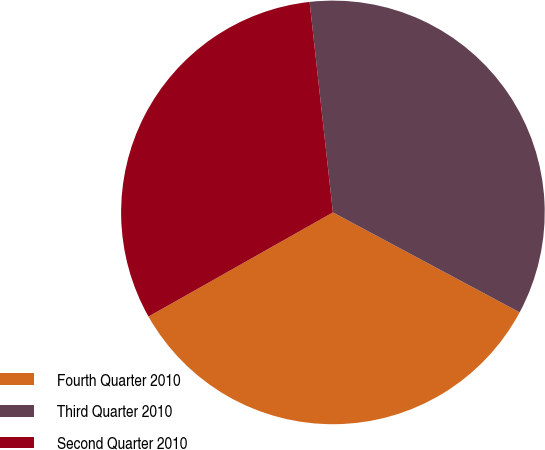Convert chart. <chart><loc_0><loc_0><loc_500><loc_500><pie_chart><fcel>Fourth Quarter 2010<fcel>Third Quarter 2010<fcel>Second Quarter 2010<nl><fcel>34.0%<fcel>34.58%<fcel>31.43%<nl></chart> 